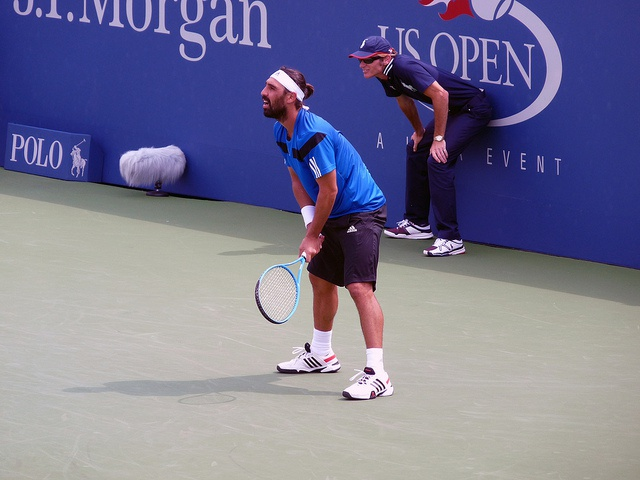Describe the objects in this image and their specific colors. I can see people in darkblue, black, lavender, maroon, and blue tones, people in darkblue, black, navy, maroon, and brown tones, and tennis racket in darkblue, lightgray, darkgray, and lightblue tones in this image. 